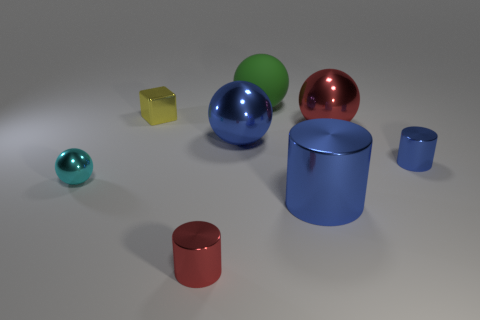Subtract all green spheres. How many blue cylinders are left? 2 Subtract all large green matte spheres. How many spheres are left? 3 Subtract 1 balls. How many balls are left? 3 Subtract all cyan balls. How many balls are left? 3 Add 2 red shiny things. How many objects exist? 10 Subtract all cyan spheres. Subtract all red cylinders. How many spheres are left? 3 Subtract all cylinders. How many objects are left? 5 Add 2 large red balls. How many large red balls exist? 3 Subtract 1 blue balls. How many objects are left? 7 Subtract all tiny red objects. Subtract all large shiny objects. How many objects are left? 4 